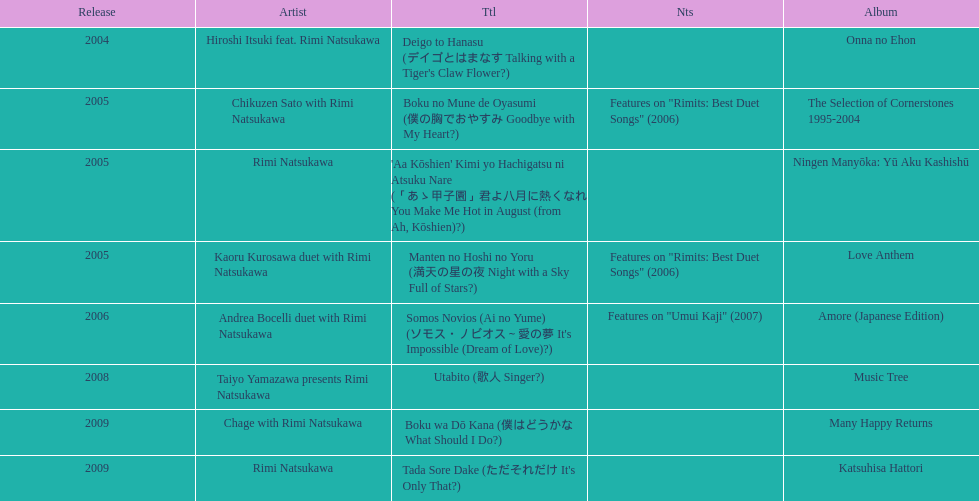Which title of the rimi natsukawa discography was released in the 2004? Deigo to Hanasu (デイゴとはまなす Talking with a Tiger's Claw Flower?). Which title has notes that features on/rimits. best duet songs\2006 Manten no Hoshi no Yoru (満天の星の夜 Night with a Sky Full of Stars?). Which title share the same notes as night with a sky full of stars? Boku no Mune de Oyasumi (僕の胸でおやすみ Goodbye with My Heart?). 